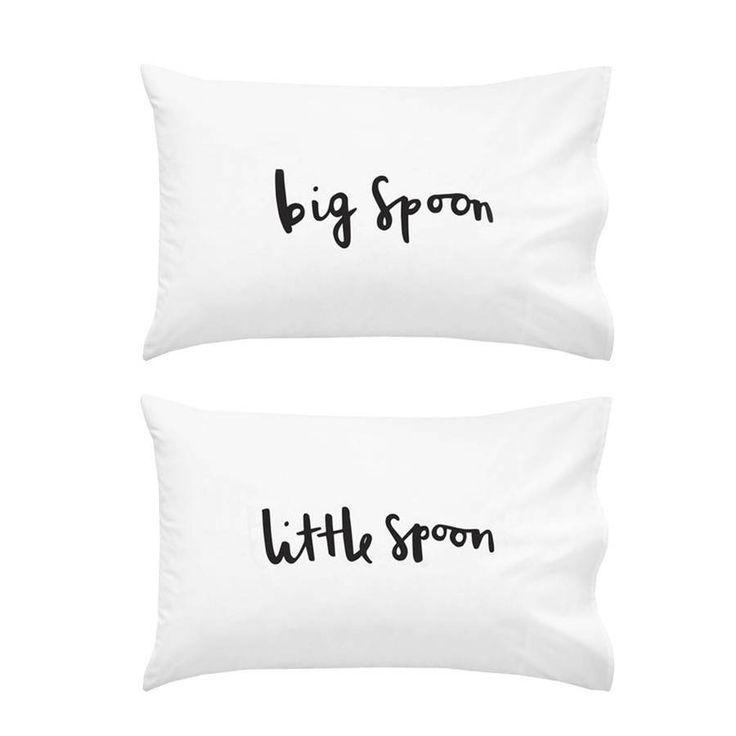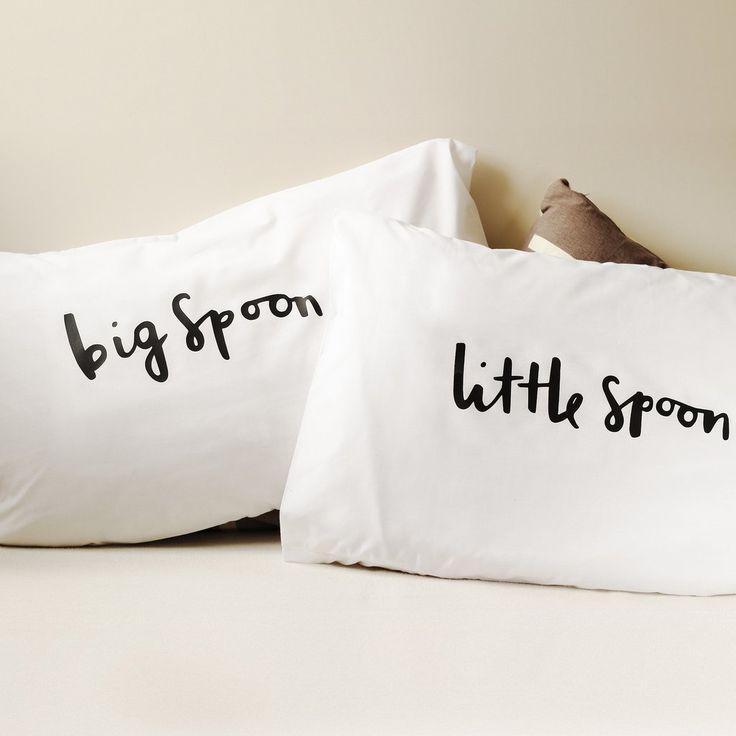The first image is the image on the left, the second image is the image on the right. For the images displayed, is the sentence "In one of the images there are 2 pillows resting against a white headboard." factually correct? Answer yes or no. No. 